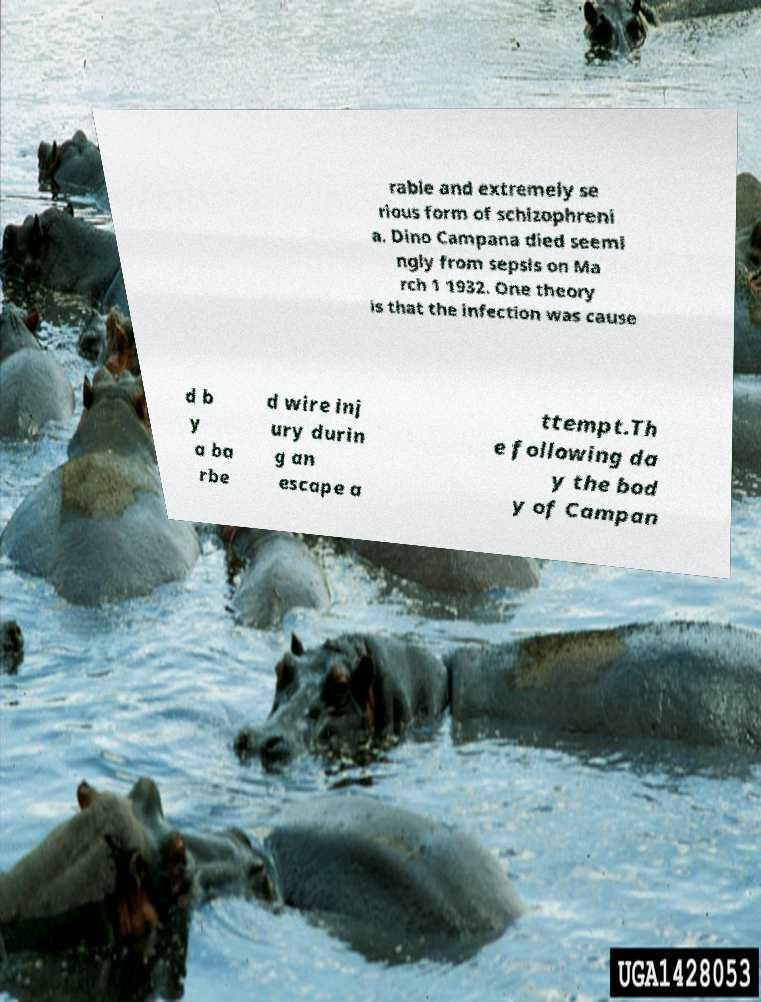Please read and relay the text visible in this image. What does it say? rable and extremely se rious form of schizophreni a. Dino Campana died seemi ngly from sepsis on Ma rch 1 1932. One theory is that the infection was cause d b y a ba rbe d wire inj ury durin g an escape a ttempt.Th e following da y the bod y of Campan 